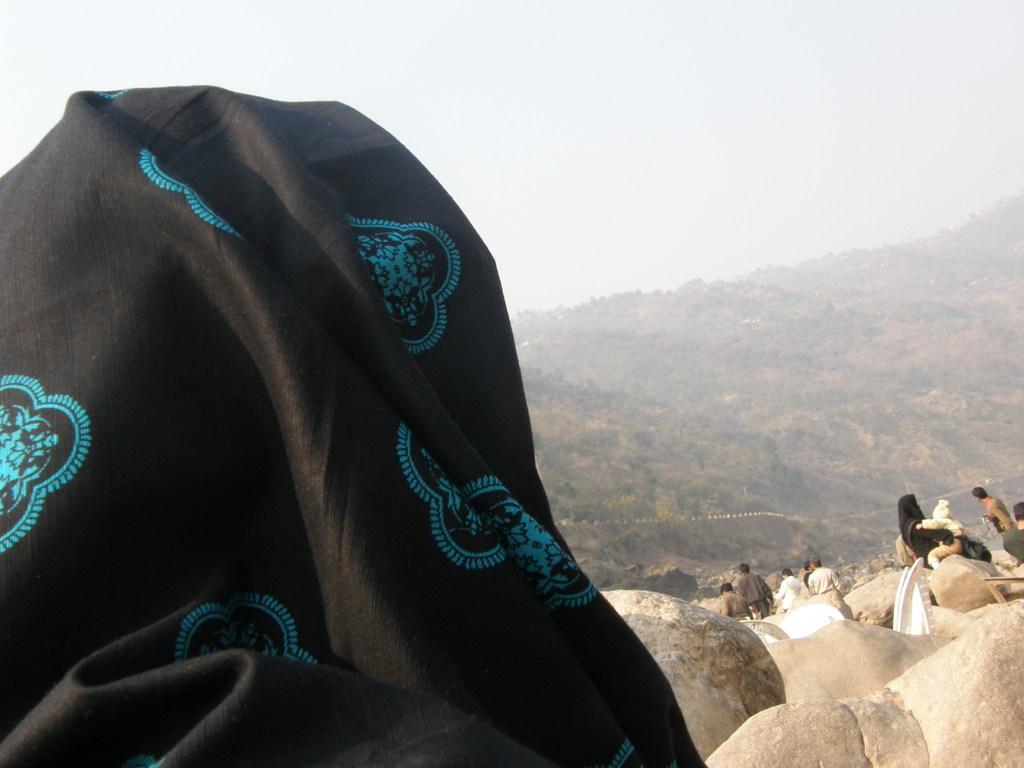Can you describe this image briefly? In this picture we can see a black cloth and in front of the cloth there are some people and stones. Behind the people there are hills and a sky. 